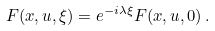Convert formula to latex. <formula><loc_0><loc_0><loc_500><loc_500>F ( x , u , \xi ) = e ^ { - i \lambda \xi } F ( x , u , 0 ) \, .</formula> 